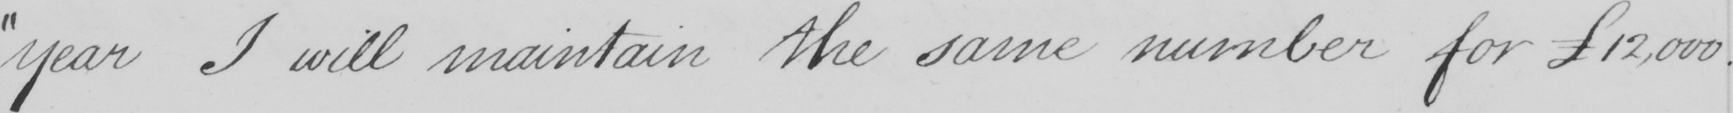Please provide the text content of this handwritten line. " year I will maintain the same number for £12,000 . 